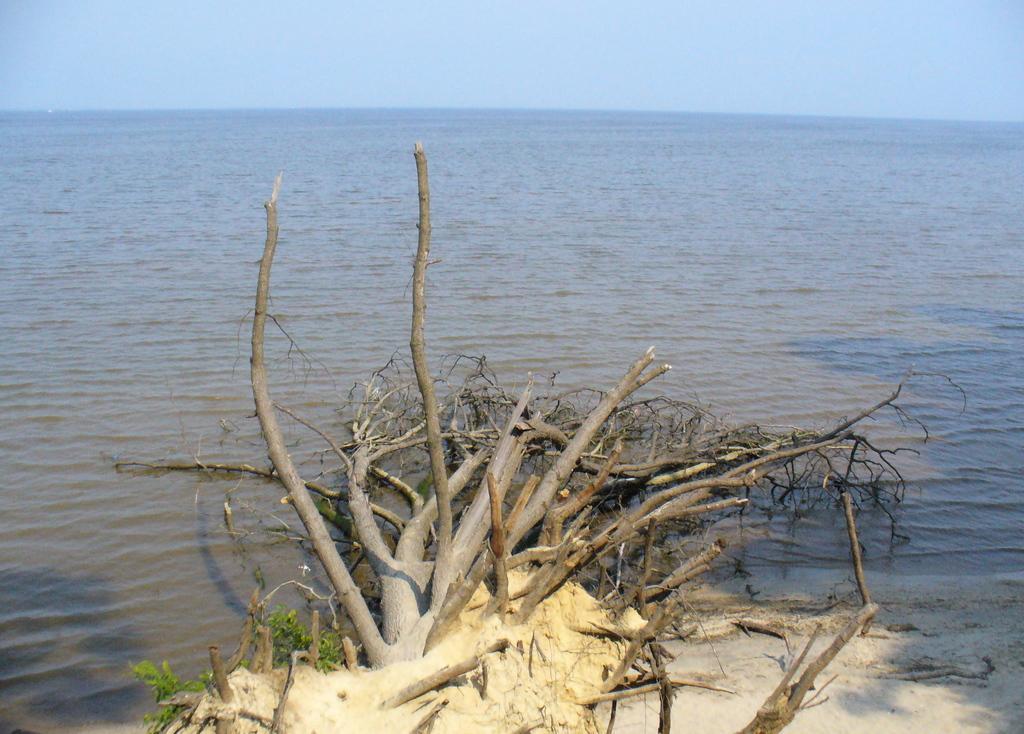Please provide a concise description of this image. This image consists of water in the middle. There is sky at the top. There is a dried tree in water. 